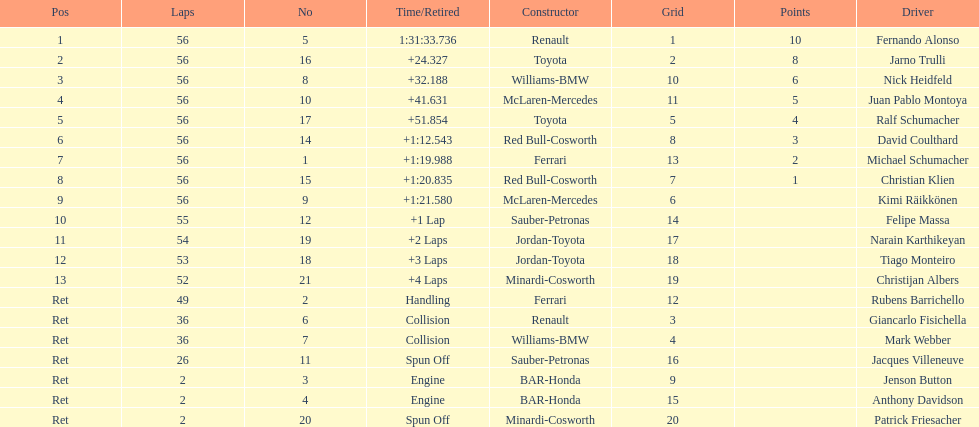Jarno trulli was not french but what nationality? Italian. 